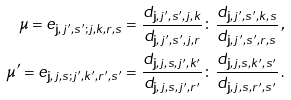<formula> <loc_0><loc_0><loc_500><loc_500>\mu = e _ { { \mathbf j } , j ^ { \prime } , s ^ { \prime } ; j , k , r , s } = \frac { d _ { { \mathbf j } , j ^ { \prime } , s ^ { \prime } , j , k } } { d _ { { \mathbf j } , j ^ { \prime } , s ^ { \prime } , j , r } } \colon \frac { d _ { { \mathbf j } , j ^ { \prime } , s ^ { \prime } , k , s } } { d _ { { \mathbf j } , j ^ { \prime } , s ^ { \prime } , r , s } } \, , \\ \mu ^ { \prime } = e _ { { \mathbf j } , j , s ; j ^ { \prime } , k ^ { \prime } , r ^ { \prime } , s ^ { \prime } } = \frac { d _ { { \mathbf j } , j , s , j ^ { \prime } , k ^ { \prime } } } { d _ { { \mathbf j } , j , s , j ^ { \prime } , r ^ { \prime } } } \colon \frac { d _ { { \mathbf j } , j , s , k ^ { \prime } , s ^ { \prime } } } { d _ { { \mathbf j } , j , s , r ^ { \prime } , s ^ { \prime } } } \, .</formula> 